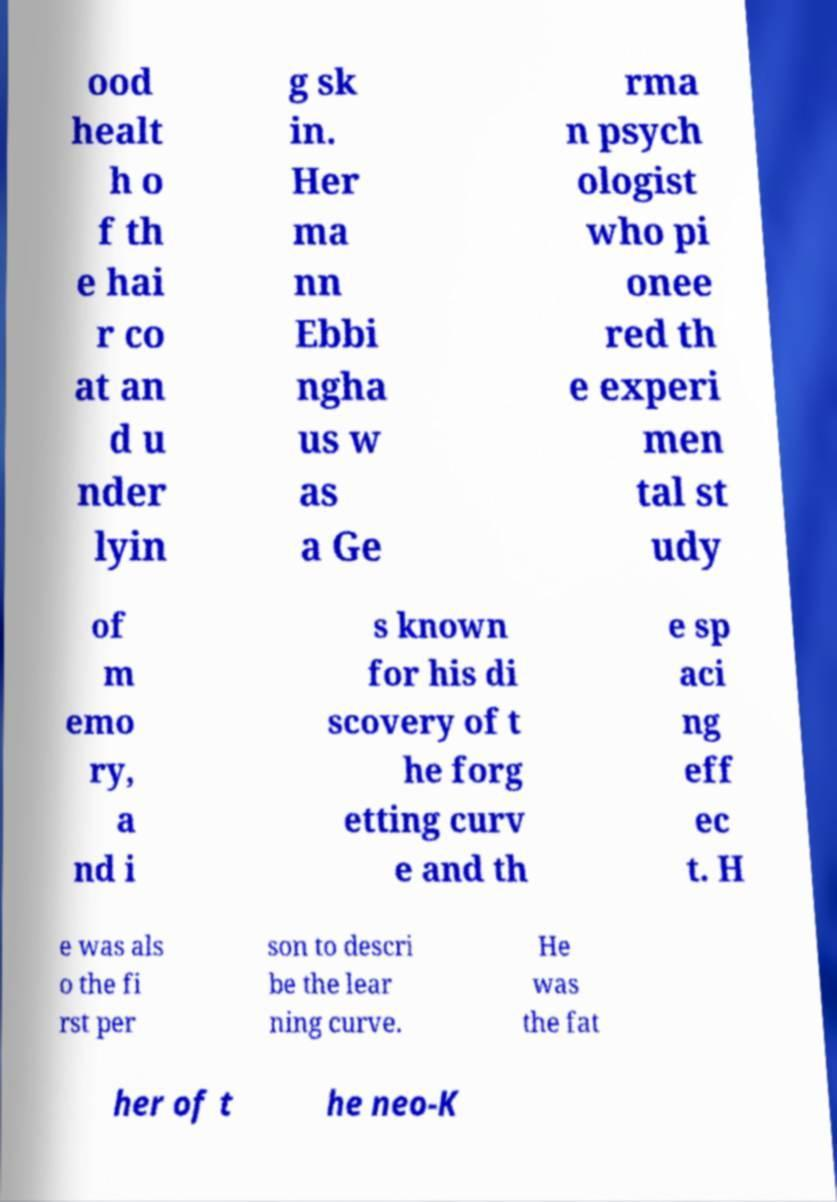Could you extract and type out the text from this image? ood healt h o f th e hai r co at an d u nder lyin g sk in. Her ma nn Ebbi ngha us w as a Ge rma n psych ologist who pi onee red th e experi men tal st udy of m emo ry, a nd i s known for his di scovery of t he forg etting curv e and th e sp aci ng eff ec t. H e was als o the fi rst per son to descri be the lear ning curve. He was the fat her of t he neo-K 